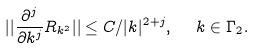<formula> <loc_0><loc_0><loc_500><loc_500>| | \frac { \partial ^ { j } } { \partial k ^ { j } } R _ { k ^ { 2 } } | | \leq C / | k | ^ { 2 + j } , \ \ k \in \Gamma _ { 2 } .</formula> 